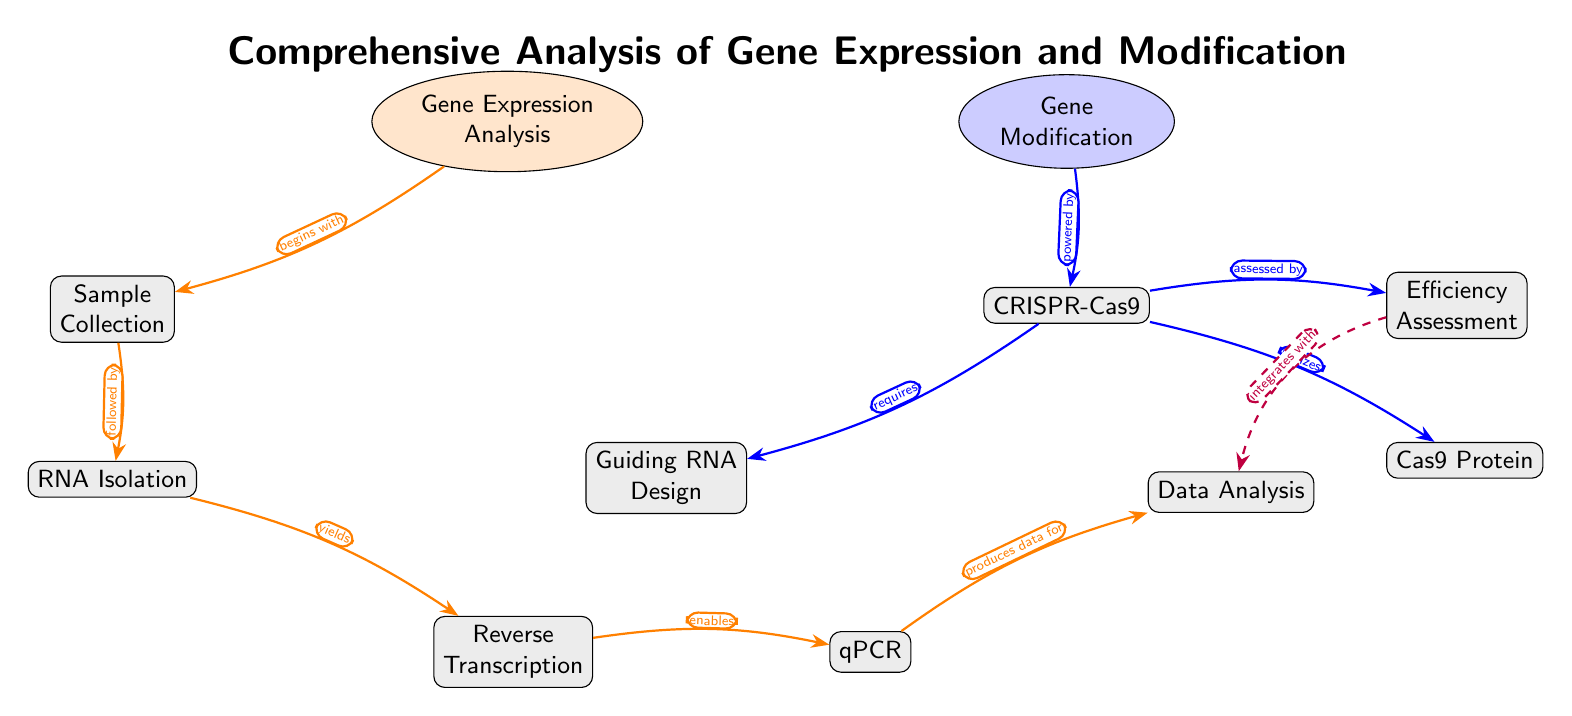What is the starting point of gene expression analysis in the diagram? The diagram shows that the starting point of gene expression analysis is "Sample Collection," which is the first node linked to "Gene Expression Analysis."
Answer: Sample Collection How many main processes are outlined in the diagram? The diagram explicitly outlines two main processes: "Gene Expression Analysis" and "Gene Modification." Each of these processes includes additional steps or components.
Answer: 2 What node is directly linked to “qPCR”? "qPCR" is directly linked to "Reverse Transcription," as indicated by the directional arrow showing that Reverse Transcription enables the qPCR process in the diagram.
Answer: Reverse Transcription What is needed for the CRISPR-Cas9 process according to the diagram? The diagram states that "Guiding RNA Design" is required for the "CRISPR-Cas9" process, as indicated by the directed edge pointing from "Guiding RNA Design" to "CRISPR-Cas9."
Answer: Guiding RNA Design What type of assessment is linked to "Efficiency Assessment"? The diagram indicates that "Efficiency Assessment" is assessed by the "Data Analysis," showing the integration of these two components with a dashed arrow.
Answer: Data Analysis What two components are utilized by the CRISPR process? The diagram reveals that the CRISPR process utilizes "Cas9 Protein" as one of its components and requires "Guiding RNA Design" as another, indicating their contribution to the CRISPR method.
Answer: Cas9 Protein and Guiding RNA Design Which two nodes in the diagram are connected by a dashed line? The dashed line connects "Efficiency Assessment" and "Data Analysis," indicating a special relationship or integration between these two components, as represented visually in the diagram.
Answer: Efficiency Assessment and Data Analysis How does Gene Expression Analysis relate to Gene Modification? The diagram illustrates that Gene Expression Analysis begins with Sample Collection and connects to Gene Modification through the process of CRISPR-Cas9, indicating a relationship based on the utilization of methods from both analyses.
Answer: Powered by CRISPR-Cas9 